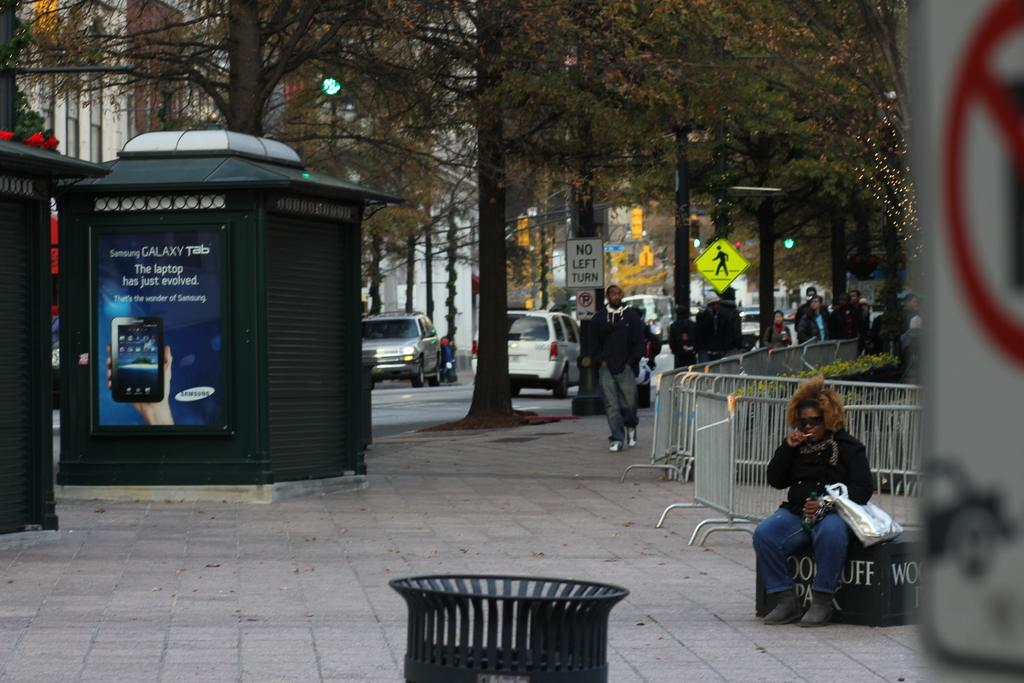Provide a one-sentence caption for the provided image. A Street scene with an ad for the Samsung Galaxy tab. 